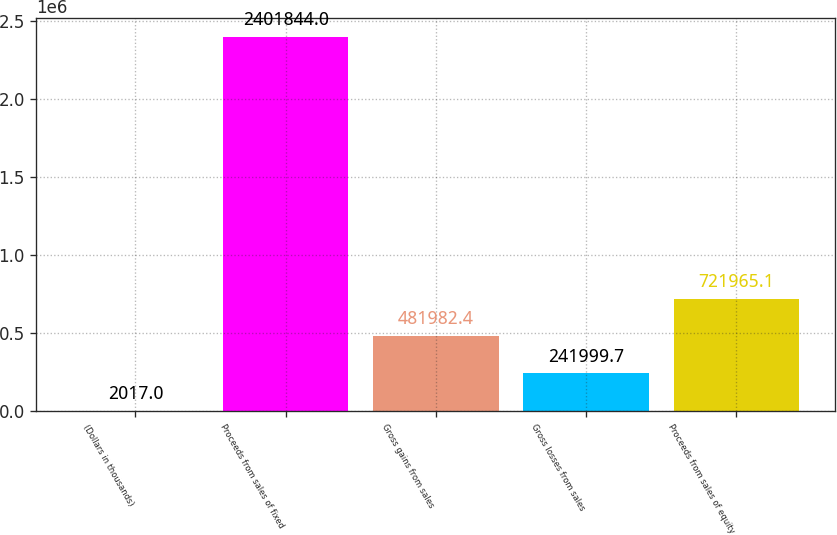<chart> <loc_0><loc_0><loc_500><loc_500><bar_chart><fcel>(Dollars in thousands)<fcel>Proceeds from sales of fixed<fcel>Gross gains from sales<fcel>Gross losses from sales<fcel>Proceeds from sales of equity<nl><fcel>2017<fcel>2.40184e+06<fcel>481982<fcel>242000<fcel>721965<nl></chart> 